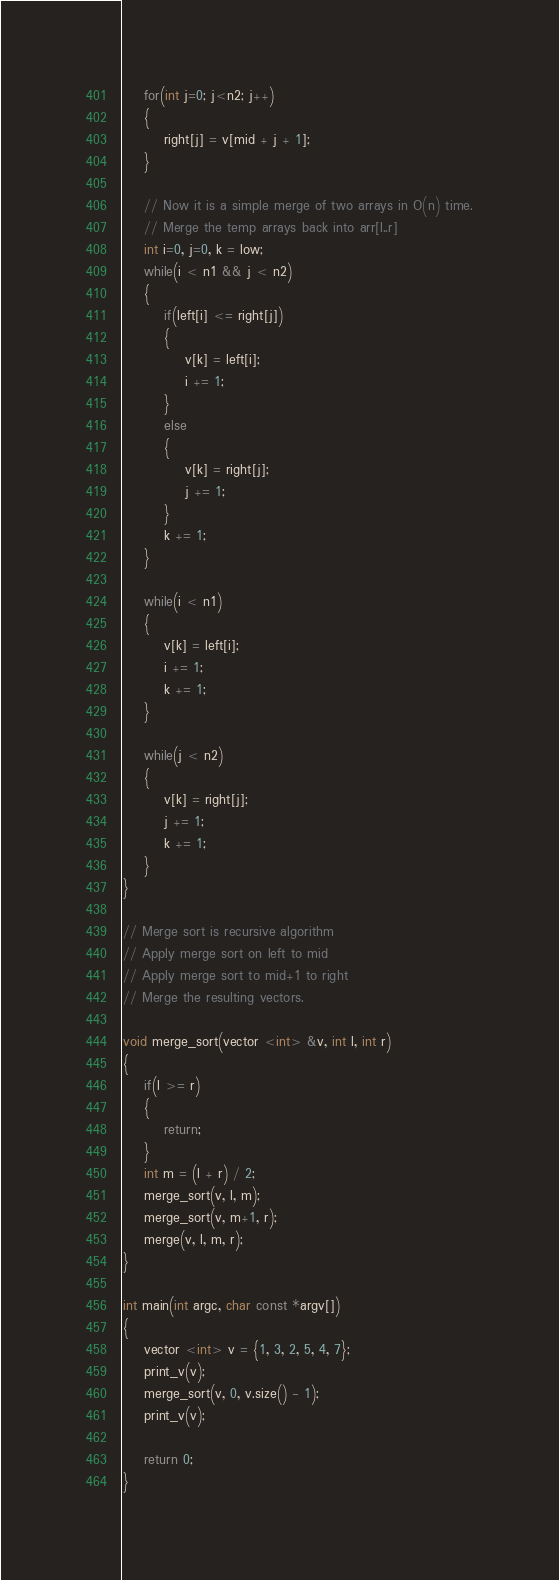<code> <loc_0><loc_0><loc_500><loc_500><_C++_>
    for(int j=0; j<n2; j++)
    {
        right[j] = v[mid + j + 1];
    }

    // Now it is a simple merge of two arrays in O(n) time.
    // Merge the temp arrays back into arr[l..r]
    int i=0, j=0, k = low;
    while(i < n1 && j < n2)
    {
        if(left[i] <= right[j])
        {
            v[k] = left[i];
            i += 1;
        }
        else
        {
            v[k] = right[j];
            j += 1;
        }
        k += 1;
    }

    while(i < n1)
    {
        v[k] = left[i];
        i += 1;
        k += 1;
    }

    while(j < n2)
    {
        v[k] = right[j];
        j += 1;
        k += 1;
    }
}

// Merge sort is recursive algorithm
// Apply merge sort on left to mid
// Apply merge sort to mid+1 to right
// Merge the resulting vectors.

void merge_sort(vector <int> &v, int l, int r)
{
    if(l >= r)
    {
        return;
    }
    int m = (l + r) / 2;
    merge_sort(v, l, m);
    merge_sort(v, m+1, r);
    merge(v, l, m, r);
}

int main(int argc, char const *argv[])
{
    vector <int> v = {1, 3, 2, 5, 4, 7};
    print_v(v);
    merge_sort(v, 0, v.size() - 1);
    print_v(v);

    return 0;
}
</code> 